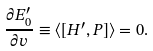<formula> <loc_0><loc_0><loc_500><loc_500>\frac { \partial E ^ { \prime } _ { 0 } } { \partial v } \equiv \langle [ H ^ { \prime } , P ] \rangle = 0 .</formula> 